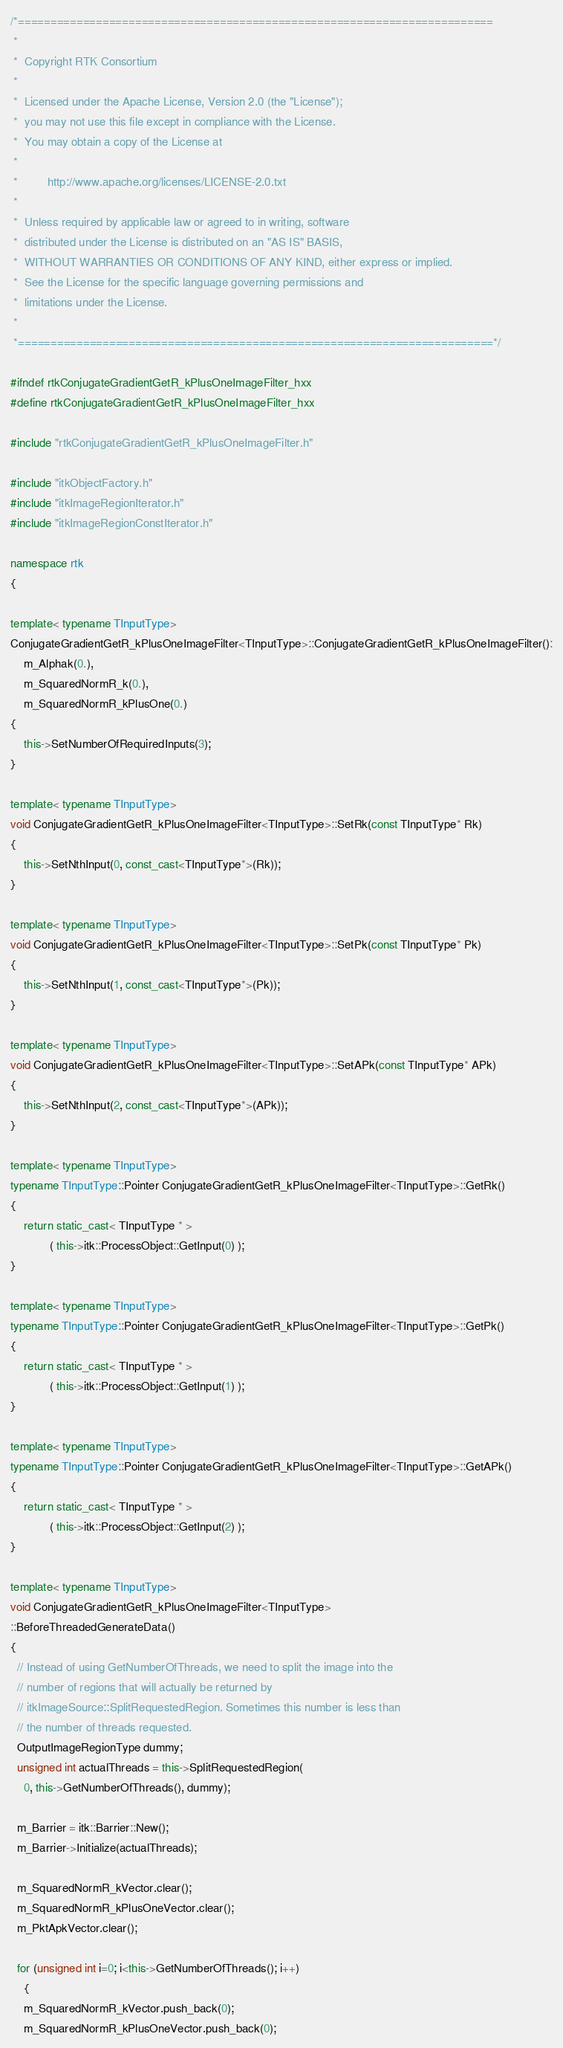Convert code to text. <code><loc_0><loc_0><loc_500><loc_500><_C++_>/*=========================================================================
 *
 *  Copyright RTK Consortium
 *
 *  Licensed under the Apache License, Version 2.0 (the "License");
 *  you may not use this file except in compliance with the License.
 *  You may obtain a copy of the License at
 *
 *         http://www.apache.org/licenses/LICENSE-2.0.txt
 *
 *  Unless required by applicable law or agreed to in writing, software
 *  distributed under the License is distributed on an "AS IS" BASIS,
 *  WITHOUT WARRANTIES OR CONDITIONS OF ANY KIND, either express or implied.
 *  See the License for the specific language governing permissions and
 *  limitations under the License.
 *
 *=========================================================================*/

#ifndef rtkConjugateGradientGetR_kPlusOneImageFilter_hxx
#define rtkConjugateGradientGetR_kPlusOneImageFilter_hxx

#include "rtkConjugateGradientGetR_kPlusOneImageFilter.h"

#include "itkObjectFactory.h"
#include "itkImageRegionIterator.h"
#include "itkImageRegionConstIterator.h"

namespace rtk
{

template< typename TInputType>
ConjugateGradientGetR_kPlusOneImageFilter<TInputType>::ConjugateGradientGetR_kPlusOneImageFilter():
    m_Alphak(0.),
    m_SquaredNormR_k(0.),
    m_SquaredNormR_kPlusOne(0.)
{
    this->SetNumberOfRequiredInputs(3);
}

template< typename TInputType>
void ConjugateGradientGetR_kPlusOneImageFilter<TInputType>::SetRk(const TInputType* Rk)
{
    this->SetNthInput(0, const_cast<TInputType*>(Rk));
}

template< typename TInputType>
void ConjugateGradientGetR_kPlusOneImageFilter<TInputType>::SetPk(const TInputType* Pk)
{
    this->SetNthInput(1, const_cast<TInputType*>(Pk));
}

template< typename TInputType>
void ConjugateGradientGetR_kPlusOneImageFilter<TInputType>::SetAPk(const TInputType* APk)
{
    this->SetNthInput(2, const_cast<TInputType*>(APk));
}

template< typename TInputType>
typename TInputType::Pointer ConjugateGradientGetR_kPlusOneImageFilter<TInputType>::GetRk()
{
    return static_cast< TInputType * >
            ( this->itk::ProcessObject::GetInput(0) );
}

template< typename TInputType>
typename TInputType::Pointer ConjugateGradientGetR_kPlusOneImageFilter<TInputType>::GetPk()
{
    return static_cast< TInputType * >
            ( this->itk::ProcessObject::GetInput(1) );
}

template< typename TInputType>
typename TInputType::Pointer ConjugateGradientGetR_kPlusOneImageFilter<TInputType>::GetAPk()
{
    return static_cast< TInputType * >
            ( this->itk::ProcessObject::GetInput(2) );
}

template< typename TInputType>
void ConjugateGradientGetR_kPlusOneImageFilter<TInputType>
::BeforeThreadedGenerateData()
{
  // Instead of using GetNumberOfThreads, we need to split the image into the
  // number of regions that will actually be returned by
  // itkImageSource::SplitRequestedRegion. Sometimes this number is less than
  // the number of threads requested.
  OutputImageRegionType dummy;
  unsigned int actualThreads = this->SplitRequestedRegion(
    0, this->GetNumberOfThreads(), dummy);

  m_Barrier = itk::Barrier::New();
  m_Barrier->Initialize(actualThreads);

  m_SquaredNormR_kVector.clear();
  m_SquaredNormR_kPlusOneVector.clear();
  m_PktApkVector.clear();

  for (unsigned int i=0; i<this->GetNumberOfThreads(); i++)
    {
    m_SquaredNormR_kVector.push_back(0);
    m_SquaredNormR_kPlusOneVector.push_back(0);</code> 